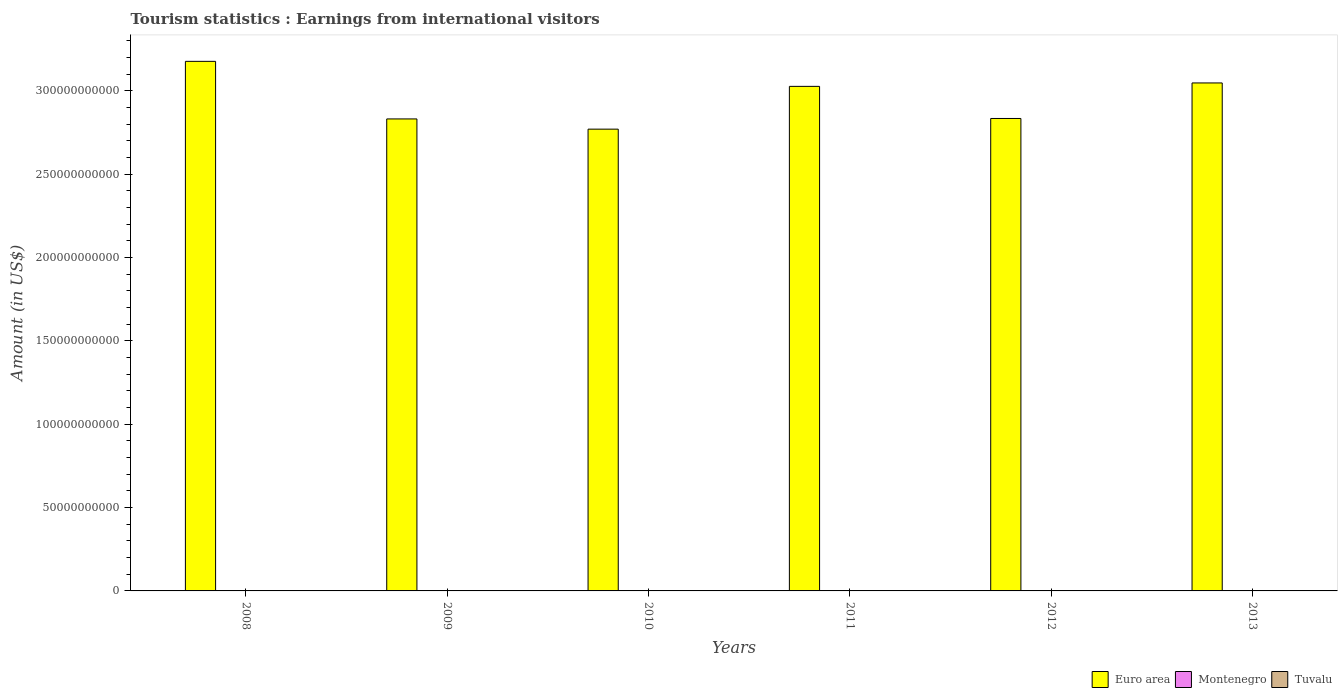Are the number of bars on each tick of the X-axis equal?
Offer a terse response. Yes. How many bars are there on the 4th tick from the left?
Provide a succinct answer. 3. How many bars are there on the 1st tick from the right?
Provide a short and direct response. 3. What is the label of the 1st group of bars from the left?
Provide a short and direct response. 2008. What is the earnings from international visitors in Euro area in 2011?
Offer a terse response. 3.03e+11. Across all years, what is the maximum earnings from international visitors in Montenegro?
Offer a very short reply. 8.10e+07. Across all years, what is the minimum earnings from international visitors in Euro area?
Give a very brief answer. 2.77e+11. In which year was the earnings from international visitors in Montenegro maximum?
Make the answer very short. 2013. What is the total earnings from international visitors in Montenegro in the graph?
Offer a terse response. 4.46e+08. What is the difference between the earnings from international visitors in Montenegro in 2012 and that in 2013?
Make the answer very short. -1.40e+07. What is the difference between the earnings from international visitors in Tuvalu in 2011 and the earnings from international visitors in Euro area in 2010?
Your answer should be compact. -2.77e+11. What is the average earnings from international visitors in Montenegro per year?
Provide a succinct answer. 7.43e+07. In the year 2009, what is the difference between the earnings from international visitors in Euro area and earnings from international visitors in Tuvalu?
Offer a terse response. 2.83e+11. What is the ratio of the earnings from international visitors in Montenegro in 2010 to that in 2013?
Ensure brevity in your answer.  0.89. Is the difference between the earnings from international visitors in Euro area in 2010 and 2011 greater than the difference between the earnings from international visitors in Tuvalu in 2010 and 2011?
Offer a terse response. No. What is the difference between the highest and the lowest earnings from international visitors in Euro area?
Your answer should be compact. 4.07e+1. In how many years, is the earnings from international visitors in Euro area greater than the average earnings from international visitors in Euro area taken over all years?
Make the answer very short. 3. What does the 3rd bar from the right in 2008 represents?
Your response must be concise. Euro area. What is the difference between two consecutive major ticks on the Y-axis?
Your response must be concise. 5.00e+1. Are the values on the major ticks of Y-axis written in scientific E-notation?
Provide a short and direct response. No. Does the graph contain any zero values?
Make the answer very short. No. What is the title of the graph?
Make the answer very short. Tourism statistics : Earnings from international visitors. Does "European Union" appear as one of the legend labels in the graph?
Offer a terse response. No. What is the label or title of the Y-axis?
Provide a succinct answer. Amount (in US$). What is the Amount (in US$) in Euro area in 2008?
Give a very brief answer. 3.18e+11. What is the Amount (in US$) of Montenegro in 2008?
Keep it short and to the point. 8.00e+07. What is the Amount (in US$) of Tuvalu in 2008?
Your response must be concise. 8.41e+06. What is the Amount (in US$) of Euro area in 2009?
Ensure brevity in your answer.  2.83e+11. What is the Amount (in US$) of Montenegro in 2009?
Provide a succinct answer. 7.60e+07. What is the Amount (in US$) in Tuvalu in 2009?
Ensure brevity in your answer.  7.50e+06. What is the Amount (in US$) of Euro area in 2010?
Provide a short and direct response. 2.77e+11. What is the Amount (in US$) in Montenegro in 2010?
Your answer should be very brief. 7.20e+07. What is the Amount (in US$) in Tuvalu in 2010?
Provide a succinct answer. 8.68e+06. What is the Amount (in US$) in Euro area in 2011?
Offer a terse response. 3.03e+11. What is the Amount (in US$) in Montenegro in 2011?
Give a very brief answer. 7.00e+07. What is the Amount (in US$) of Tuvalu in 2011?
Your response must be concise. 1.15e+07. What is the Amount (in US$) in Euro area in 2012?
Provide a short and direct response. 2.83e+11. What is the Amount (in US$) in Montenegro in 2012?
Ensure brevity in your answer.  6.70e+07. What is the Amount (in US$) in Tuvalu in 2012?
Your response must be concise. 1.15e+07. What is the Amount (in US$) in Euro area in 2013?
Make the answer very short. 3.05e+11. What is the Amount (in US$) of Montenegro in 2013?
Your answer should be very brief. 8.10e+07. What is the Amount (in US$) in Tuvalu in 2013?
Provide a short and direct response. 7.56e+06. Across all years, what is the maximum Amount (in US$) of Euro area?
Keep it short and to the point. 3.18e+11. Across all years, what is the maximum Amount (in US$) in Montenegro?
Provide a short and direct response. 8.10e+07. Across all years, what is the maximum Amount (in US$) in Tuvalu?
Your answer should be very brief. 1.15e+07. Across all years, what is the minimum Amount (in US$) in Euro area?
Your answer should be very brief. 2.77e+11. Across all years, what is the minimum Amount (in US$) in Montenegro?
Provide a short and direct response. 6.70e+07. Across all years, what is the minimum Amount (in US$) of Tuvalu?
Offer a very short reply. 7.50e+06. What is the total Amount (in US$) of Euro area in the graph?
Your answer should be compact. 1.77e+12. What is the total Amount (in US$) in Montenegro in the graph?
Give a very brief answer. 4.46e+08. What is the total Amount (in US$) of Tuvalu in the graph?
Ensure brevity in your answer.  5.51e+07. What is the difference between the Amount (in US$) in Euro area in 2008 and that in 2009?
Offer a very short reply. 3.45e+1. What is the difference between the Amount (in US$) of Tuvalu in 2008 and that in 2009?
Your response must be concise. 9.10e+05. What is the difference between the Amount (in US$) of Euro area in 2008 and that in 2010?
Your answer should be very brief. 4.07e+1. What is the difference between the Amount (in US$) in Montenegro in 2008 and that in 2010?
Provide a succinct answer. 8.00e+06. What is the difference between the Amount (in US$) in Tuvalu in 2008 and that in 2010?
Offer a terse response. -2.70e+05. What is the difference between the Amount (in US$) of Euro area in 2008 and that in 2011?
Provide a short and direct response. 1.50e+1. What is the difference between the Amount (in US$) in Montenegro in 2008 and that in 2011?
Offer a very short reply. 1.00e+07. What is the difference between the Amount (in US$) in Tuvalu in 2008 and that in 2011?
Offer a very short reply. -3.05e+06. What is the difference between the Amount (in US$) in Euro area in 2008 and that in 2012?
Your answer should be very brief. 3.43e+1. What is the difference between the Amount (in US$) in Montenegro in 2008 and that in 2012?
Provide a succinct answer. 1.30e+07. What is the difference between the Amount (in US$) in Tuvalu in 2008 and that in 2012?
Offer a very short reply. -3.11e+06. What is the difference between the Amount (in US$) of Euro area in 2008 and that in 2013?
Your answer should be compact. 1.29e+1. What is the difference between the Amount (in US$) in Tuvalu in 2008 and that in 2013?
Ensure brevity in your answer.  8.50e+05. What is the difference between the Amount (in US$) in Euro area in 2009 and that in 2010?
Keep it short and to the point. 6.13e+09. What is the difference between the Amount (in US$) in Montenegro in 2009 and that in 2010?
Make the answer very short. 4.00e+06. What is the difference between the Amount (in US$) of Tuvalu in 2009 and that in 2010?
Your answer should be compact. -1.18e+06. What is the difference between the Amount (in US$) in Euro area in 2009 and that in 2011?
Give a very brief answer. -1.95e+1. What is the difference between the Amount (in US$) of Montenegro in 2009 and that in 2011?
Offer a very short reply. 6.00e+06. What is the difference between the Amount (in US$) of Tuvalu in 2009 and that in 2011?
Make the answer very short. -3.96e+06. What is the difference between the Amount (in US$) in Euro area in 2009 and that in 2012?
Offer a very short reply. -2.75e+08. What is the difference between the Amount (in US$) of Montenegro in 2009 and that in 2012?
Offer a terse response. 9.00e+06. What is the difference between the Amount (in US$) of Tuvalu in 2009 and that in 2012?
Keep it short and to the point. -4.02e+06. What is the difference between the Amount (in US$) of Euro area in 2009 and that in 2013?
Your answer should be compact. -2.16e+1. What is the difference between the Amount (in US$) in Montenegro in 2009 and that in 2013?
Your response must be concise. -5.00e+06. What is the difference between the Amount (in US$) of Tuvalu in 2009 and that in 2013?
Ensure brevity in your answer.  -6.00e+04. What is the difference between the Amount (in US$) of Euro area in 2010 and that in 2011?
Keep it short and to the point. -2.57e+1. What is the difference between the Amount (in US$) in Tuvalu in 2010 and that in 2011?
Your answer should be compact. -2.78e+06. What is the difference between the Amount (in US$) in Euro area in 2010 and that in 2012?
Provide a short and direct response. -6.41e+09. What is the difference between the Amount (in US$) in Montenegro in 2010 and that in 2012?
Your answer should be very brief. 5.00e+06. What is the difference between the Amount (in US$) of Tuvalu in 2010 and that in 2012?
Give a very brief answer. -2.84e+06. What is the difference between the Amount (in US$) of Euro area in 2010 and that in 2013?
Make the answer very short. -2.77e+1. What is the difference between the Amount (in US$) in Montenegro in 2010 and that in 2013?
Your answer should be very brief. -9.00e+06. What is the difference between the Amount (in US$) in Tuvalu in 2010 and that in 2013?
Your answer should be very brief. 1.12e+06. What is the difference between the Amount (in US$) in Euro area in 2011 and that in 2012?
Give a very brief answer. 1.93e+1. What is the difference between the Amount (in US$) in Tuvalu in 2011 and that in 2012?
Ensure brevity in your answer.  -6.00e+04. What is the difference between the Amount (in US$) of Euro area in 2011 and that in 2013?
Offer a terse response. -2.06e+09. What is the difference between the Amount (in US$) in Montenegro in 2011 and that in 2013?
Make the answer very short. -1.10e+07. What is the difference between the Amount (in US$) in Tuvalu in 2011 and that in 2013?
Your answer should be compact. 3.90e+06. What is the difference between the Amount (in US$) in Euro area in 2012 and that in 2013?
Offer a very short reply. -2.13e+1. What is the difference between the Amount (in US$) of Montenegro in 2012 and that in 2013?
Offer a very short reply. -1.40e+07. What is the difference between the Amount (in US$) in Tuvalu in 2012 and that in 2013?
Ensure brevity in your answer.  3.96e+06. What is the difference between the Amount (in US$) in Euro area in 2008 and the Amount (in US$) in Montenegro in 2009?
Your answer should be very brief. 3.18e+11. What is the difference between the Amount (in US$) in Euro area in 2008 and the Amount (in US$) in Tuvalu in 2009?
Your answer should be compact. 3.18e+11. What is the difference between the Amount (in US$) of Montenegro in 2008 and the Amount (in US$) of Tuvalu in 2009?
Ensure brevity in your answer.  7.25e+07. What is the difference between the Amount (in US$) in Euro area in 2008 and the Amount (in US$) in Montenegro in 2010?
Keep it short and to the point. 3.18e+11. What is the difference between the Amount (in US$) in Euro area in 2008 and the Amount (in US$) in Tuvalu in 2010?
Offer a terse response. 3.18e+11. What is the difference between the Amount (in US$) of Montenegro in 2008 and the Amount (in US$) of Tuvalu in 2010?
Provide a succinct answer. 7.13e+07. What is the difference between the Amount (in US$) of Euro area in 2008 and the Amount (in US$) of Montenegro in 2011?
Keep it short and to the point. 3.18e+11. What is the difference between the Amount (in US$) of Euro area in 2008 and the Amount (in US$) of Tuvalu in 2011?
Provide a succinct answer. 3.18e+11. What is the difference between the Amount (in US$) in Montenegro in 2008 and the Amount (in US$) in Tuvalu in 2011?
Your response must be concise. 6.85e+07. What is the difference between the Amount (in US$) in Euro area in 2008 and the Amount (in US$) in Montenegro in 2012?
Your answer should be compact. 3.18e+11. What is the difference between the Amount (in US$) of Euro area in 2008 and the Amount (in US$) of Tuvalu in 2012?
Provide a succinct answer. 3.18e+11. What is the difference between the Amount (in US$) in Montenegro in 2008 and the Amount (in US$) in Tuvalu in 2012?
Make the answer very short. 6.85e+07. What is the difference between the Amount (in US$) of Euro area in 2008 and the Amount (in US$) of Montenegro in 2013?
Provide a succinct answer. 3.18e+11. What is the difference between the Amount (in US$) of Euro area in 2008 and the Amount (in US$) of Tuvalu in 2013?
Give a very brief answer. 3.18e+11. What is the difference between the Amount (in US$) in Montenegro in 2008 and the Amount (in US$) in Tuvalu in 2013?
Offer a terse response. 7.24e+07. What is the difference between the Amount (in US$) in Euro area in 2009 and the Amount (in US$) in Montenegro in 2010?
Provide a short and direct response. 2.83e+11. What is the difference between the Amount (in US$) in Euro area in 2009 and the Amount (in US$) in Tuvalu in 2010?
Your answer should be very brief. 2.83e+11. What is the difference between the Amount (in US$) in Montenegro in 2009 and the Amount (in US$) in Tuvalu in 2010?
Your response must be concise. 6.73e+07. What is the difference between the Amount (in US$) in Euro area in 2009 and the Amount (in US$) in Montenegro in 2011?
Offer a very short reply. 2.83e+11. What is the difference between the Amount (in US$) of Euro area in 2009 and the Amount (in US$) of Tuvalu in 2011?
Make the answer very short. 2.83e+11. What is the difference between the Amount (in US$) in Montenegro in 2009 and the Amount (in US$) in Tuvalu in 2011?
Make the answer very short. 6.45e+07. What is the difference between the Amount (in US$) in Euro area in 2009 and the Amount (in US$) in Montenegro in 2012?
Provide a short and direct response. 2.83e+11. What is the difference between the Amount (in US$) of Euro area in 2009 and the Amount (in US$) of Tuvalu in 2012?
Provide a short and direct response. 2.83e+11. What is the difference between the Amount (in US$) of Montenegro in 2009 and the Amount (in US$) of Tuvalu in 2012?
Your answer should be compact. 6.45e+07. What is the difference between the Amount (in US$) in Euro area in 2009 and the Amount (in US$) in Montenegro in 2013?
Your answer should be compact. 2.83e+11. What is the difference between the Amount (in US$) in Euro area in 2009 and the Amount (in US$) in Tuvalu in 2013?
Provide a short and direct response. 2.83e+11. What is the difference between the Amount (in US$) of Montenegro in 2009 and the Amount (in US$) of Tuvalu in 2013?
Keep it short and to the point. 6.84e+07. What is the difference between the Amount (in US$) of Euro area in 2010 and the Amount (in US$) of Montenegro in 2011?
Your answer should be compact. 2.77e+11. What is the difference between the Amount (in US$) of Euro area in 2010 and the Amount (in US$) of Tuvalu in 2011?
Make the answer very short. 2.77e+11. What is the difference between the Amount (in US$) in Montenegro in 2010 and the Amount (in US$) in Tuvalu in 2011?
Ensure brevity in your answer.  6.05e+07. What is the difference between the Amount (in US$) in Euro area in 2010 and the Amount (in US$) in Montenegro in 2012?
Offer a very short reply. 2.77e+11. What is the difference between the Amount (in US$) in Euro area in 2010 and the Amount (in US$) in Tuvalu in 2012?
Make the answer very short. 2.77e+11. What is the difference between the Amount (in US$) of Montenegro in 2010 and the Amount (in US$) of Tuvalu in 2012?
Keep it short and to the point. 6.05e+07. What is the difference between the Amount (in US$) of Euro area in 2010 and the Amount (in US$) of Montenegro in 2013?
Keep it short and to the point. 2.77e+11. What is the difference between the Amount (in US$) of Euro area in 2010 and the Amount (in US$) of Tuvalu in 2013?
Make the answer very short. 2.77e+11. What is the difference between the Amount (in US$) in Montenegro in 2010 and the Amount (in US$) in Tuvalu in 2013?
Make the answer very short. 6.44e+07. What is the difference between the Amount (in US$) of Euro area in 2011 and the Amount (in US$) of Montenegro in 2012?
Your answer should be very brief. 3.03e+11. What is the difference between the Amount (in US$) in Euro area in 2011 and the Amount (in US$) in Tuvalu in 2012?
Offer a very short reply. 3.03e+11. What is the difference between the Amount (in US$) in Montenegro in 2011 and the Amount (in US$) in Tuvalu in 2012?
Your answer should be very brief. 5.85e+07. What is the difference between the Amount (in US$) in Euro area in 2011 and the Amount (in US$) in Montenegro in 2013?
Your response must be concise. 3.03e+11. What is the difference between the Amount (in US$) of Euro area in 2011 and the Amount (in US$) of Tuvalu in 2013?
Your answer should be compact. 3.03e+11. What is the difference between the Amount (in US$) in Montenegro in 2011 and the Amount (in US$) in Tuvalu in 2013?
Offer a very short reply. 6.24e+07. What is the difference between the Amount (in US$) in Euro area in 2012 and the Amount (in US$) in Montenegro in 2013?
Provide a short and direct response. 2.83e+11. What is the difference between the Amount (in US$) in Euro area in 2012 and the Amount (in US$) in Tuvalu in 2013?
Ensure brevity in your answer.  2.83e+11. What is the difference between the Amount (in US$) of Montenegro in 2012 and the Amount (in US$) of Tuvalu in 2013?
Give a very brief answer. 5.94e+07. What is the average Amount (in US$) in Euro area per year?
Give a very brief answer. 2.95e+11. What is the average Amount (in US$) of Montenegro per year?
Keep it short and to the point. 7.43e+07. What is the average Amount (in US$) of Tuvalu per year?
Your answer should be compact. 9.19e+06. In the year 2008, what is the difference between the Amount (in US$) in Euro area and Amount (in US$) in Montenegro?
Your answer should be compact. 3.18e+11. In the year 2008, what is the difference between the Amount (in US$) in Euro area and Amount (in US$) in Tuvalu?
Make the answer very short. 3.18e+11. In the year 2008, what is the difference between the Amount (in US$) in Montenegro and Amount (in US$) in Tuvalu?
Offer a terse response. 7.16e+07. In the year 2009, what is the difference between the Amount (in US$) in Euro area and Amount (in US$) in Montenegro?
Ensure brevity in your answer.  2.83e+11. In the year 2009, what is the difference between the Amount (in US$) in Euro area and Amount (in US$) in Tuvalu?
Make the answer very short. 2.83e+11. In the year 2009, what is the difference between the Amount (in US$) of Montenegro and Amount (in US$) of Tuvalu?
Make the answer very short. 6.85e+07. In the year 2010, what is the difference between the Amount (in US$) of Euro area and Amount (in US$) of Montenegro?
Offer a very short reply. 2.77e+11. In the year 2010, what is the difference between the Amount (in US$) of Euro area and Amount (in US$) of Tuvalu?
Offer a terse response. 2.77e+11. In the year 2010, what is the difference between the Amount (in US$) in Montenegro and Amount (in US$) in Tuvalu?
Provide a succinct answer. 6.33e+07. In the year 2011, what is the difference between the Amount (in US$) of Euro area and Amount (in US$) of Montenegro?
Your response must be concise. 3.03e+11. In the year 2011, what is the difference between the Amount (in US$) of Euro area and Amount (in US$) of Tuvalu?
Offer a terse response. 3.03e+11. In the year 2011, what is the difference between the Amount (in US$) of Montenegro and Amount (in US$) of Tuvalu?
Your answer should be compact. 5.85e+07. In the year 2012, what is the difference between the Amount (in US$) in Euro area and Amount (in US$) in Montenegro?
Your answer should be compact. 2.83e+11. In the year 2012, what is the difference between the Amount (in US$) in Euro area and Amount (in US$) in Tuvalu?
Provide a succinct answer. 2.83e+11. In the year 2012, what is the difference between the Amount (in US$) of Montenegro and Amount (in US$) of Tuvalu?
Offer a terse response. 5.55e+07. In the year 2013, what is the difference between the Amount (in US$) in Euro area and Amount (in US$) in Montenegro?
Give a very brief answer. 3.05e+11. In the year 2013, what is the difference between the Amount (in US$) of Euro area and Amount (in US$) of Tuvalu?
Provide a succinct answer. 3.05e+11. In the year 2013, what is the difference between the Amount (in US$) in Montenegro and Amount (in US$) in Tuvalu?
Keep it short and to the point. 7.34e+07. What is the ratio of the Amount (in US$) of Euro area in 2008 to that in 2009?
Provide a short and direct response. 1.12. What is the ratio of the Amount (in US$) in Montenegro in 2008 to that in 2009?
Keep it short and to the point. 1.05. What is the ratio of the Amount (in US$) of Tuvalu in 2008 to that in 2009?
Give a very brief answer. 1.12. What is the ratio of the Amount (in US$) of Euro area in 2008 to that in 2010?
Your answer should be compact. 1.15. What is the ratio of the Amount (in US$) of Tuvalu in 2008 to that in 2010?
Keep it short and to the point. 0.97. What is the ratio of the Amount (in US$) of Euro area in 2008 to that in 2011?
Offer a terse response. 1.05. What is the ratio of the Amount (in US$) of Montenegro in 2008 to that in 2011?
Provide a short and direct response. 1.14. What is the ratio of the Amount (in US$) of Tuvalu in 2008 to that in 2011?
Give a very brief answer. 0.73. What is the ratio of the Amount (in US$) in Euro area in 2008 to that in 2012?
Provide a succinct answer. 1.12. What is the ratio of the Amount (in US$) of Montenegro in 2008 to that in 2012?
Offer a terse response. 1.19. What is the ratio of the Amount (in US$) in Tuvalu in 2008 to that in 2012?
Give a very brief answer. 0.73. What is the ratio of the Amount (in US$) of Euro area in 2008 to that in 2013?
Offer a very short reply. 1.04. What is the ratio of the Amount (in US$) in Tuvalu in 2008 to that in 2013?
Offer a terse response. 1.11. What is the ratio of the Amount (in US$) in Euro area in 2009 to that in 2010?
Your answer should be compact. 1.02. What is the ratio of the Amount (in US$) in Montenegro in 2009 to that in 2010?
Your answer should be very brief. 1.06. What is the ratio of the Amount (in US$) of Tuvalu in 2009 to that in 2010?
Offer a very short reply. 0.86. What is the ratio of the Amount (in US$) in Euro area in 2009 to that in 2011?
Your response must be concise. 0.94. What is the ratio of the Amount (in US$) in Montenegro in 2009 to that in 2011?
Your response must be concise. 1.09. What is the ratio of the Amount (in US$) of Tuvalu in 2009 to that in 2011?
Your answer should be compact. 0.65. What is the ratio of the Amount (in US$) of Montenegro in 2009 to that in 2012?
Provide a succinct answer. 1.13. What is the ratio of the Amount (in US$) of Tuvalu in 2009 to that in 2012?
Provide a short and direct response. 0.65. What is the ratio of the Amount (in US$) of Euro area in 2009 to that in 2013?
Provide a short and direct response. 0.93. What is the ratio of the Amount (in US$) of Montenegro in 2009 to that in 2013?
Offer a terse response. 0.94. What is the ratio of the Amount (in US$) in Tuvalu in 2009 to that in 2013?
Provide a succinct answer. 0.99. What is the ratio of the Amount (in US$) in Euro area in 2010 to that in 2011?
Ensure brevity in your answer.  0.92. What is the ratio of the Amount (in US$) in Montenegro in 2010 to that in 2011?
Your answer should be very brief. 1.03. What is the ratio of the Amount (in US$) in Tuvalu in 2010 to that in 2011?
Provide a succinct answer. 0.76. What is the ratio of the Amount (in US$) of Euro area in 2010 to that in 2012?
Offer a terse response. 0.98. What is the ratio of the Amount (in US$) of Montenegro in 2010 to that in 2012?
Your answer should be very brief. 1.07. What is the ratio of the Amount (in US$) of Tuvalu in 2010 to that in 2012?
Your answer should be compact. 0.75. What is the ratio of the Amount (in US$) in Euro area in 2010 to that in 2013?
Offer a very short reply. 0.91. What is the ratio of the Amount (in US$) of Montenegro in 2010 to that in 2013?
Offer a very short reply. 0.89. What is the ratio of the Amount (in US$) of Tuvalu in 2010 to that in 2013?
Provide a short and direct response. 1.15. What is the ratio of the Amount (in US$) of Euro area in 2011 to that in 2012?
Provide a short and direct response. 1.07. What is the ratio of the Amount (in US$) of Montenegro in 2011 to that in 2012?
Make the answer very short. 1.04. What is the ratio of the Amount (in US$) in Tuvalu in 2011 to that in 2012?
Offer a terse response. 0.99. What is the ratio of the Amount (in US$) of Euro area in 2011 to that in 2013?
Keep it short and to the point. 0.99. What is the ratio of the Amount (in US$) in Montenegro in 2011 to that in 2013?
Make the answer very short. 0.86. What is the ratio of the Amount (in US$) of Tuvalu in 2011 to that in 2013?
Keep it short and to the point. 1.52. What is the ratio of the Amount (in US$) in Euro area in 2012 to that in 2013?
Your response must be concise. 0.93. What is the ratio of the Amount (in US$) in Montenegro in 2012 to that in 2013?
Offer a very short reply. 0.83. What is the ratio of the Amount (in US$) of Tuvalu in 2012 to that in 2013?
Offer a very short reply. 1.52. What is the difference between the highest and the second highest Amount (in US$) of Euro area?
Keep it short and to the point. 1.29e+1. What is the difference between the highest and the lowest Amount (in US$) in Euro area?
Your answer should be very brief. 4.07e+1. What is the difference between the highest and the lowest Amount (in US$) of Montenegro?
Your answer should be compact. 1.40e+07. What is the difference between the highest and the lowest Amount (in US$) in Tuvalu?
Ensure brevity in your answer.  4.02e+06. 